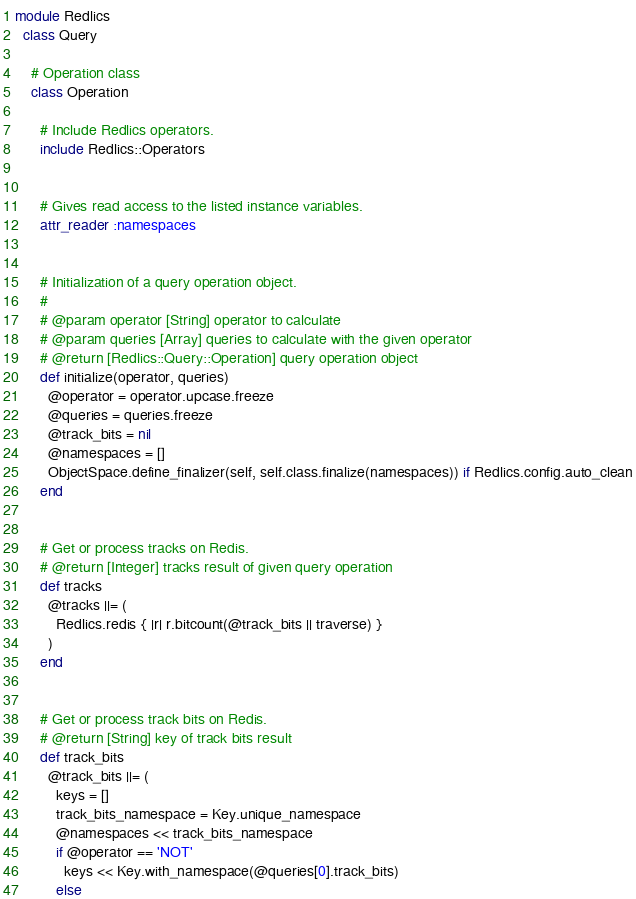Convert code to text. <code><loc_0><loc_0><loc_500><loc_500><_Ruby_>module Redlics
  class Query

    # Operation class
    class Operation

      # Include Redlics operators.
      include Redlics::Operators


      # Gives read access to the listed instance variables.
      attr_reader :namespaces


      # Initialization of a query operation object.
      #
      # @param operator [String] operator to calculate
      # @param queries [Array] queries to calculate with the given operator
      # @return [Redlics::Query::Operation] query operation object
      def initialize(operator, queries)
        @operator = operator.upcase.freeze
        @queries = queries.freeze
        @track_bits = nil
        @namespaces = []
        ObjectSpace.define_finalizer(self, self.class.finalize(namespaces)) if Redlics.config.auto_clean
      end


      # Get or process tracks on Redis.
      # @return [Integer] tracks result of given query operation
      def tracks
        @tracks ||= (
          Redlics.redis { |r| r.bitcount(@track_bits || traverse) }
        )
      end


      # Get or process track bits on Redis.
      # @return [String] key of track bits result
      def track_bits
        @track_bits ||= (
          keys = []
          track_bits_namespace = Key.unique_namespace
          @namespaces << track_bits_namespace
          if @operator == 'NOT'
            keys << Key.with_namespace(@queries[0].track_bits)
          else</code> 